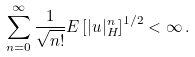Convert formula to latex. <formula><loc_0><loc_0><loc_500><loc_500>\sum _ { n = 0 } ^ { \infty } \frac { 1 } { \sqrt { n ! } } E \left [ | u | _ { H } ^ { n } \right ] ^ { 1 / 2 } < \infty \, .</formula> 